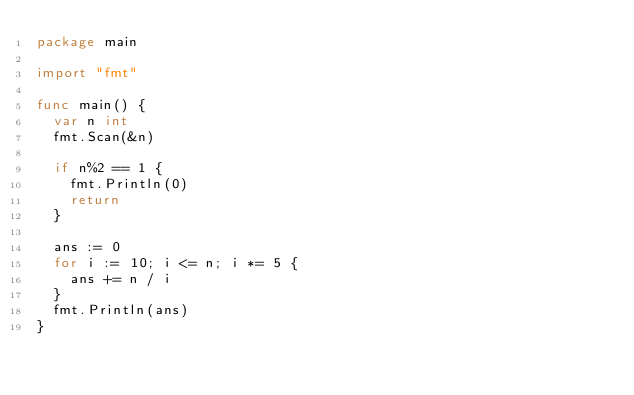Convert code to text. <code><loc_0><loc_0><loc_500><loc_500><_Go_>package main

import "fmt"

func main() {
	var n int
	fmt.Scan(&n)

	if n%2 == 1 {
		fmt.Println(0)
		return
	}

	ans := 0
	for i := 10; i <= n; i *= 5 {
		ans += n / i
	}
	fmt.Println(ans)
}
</code> 